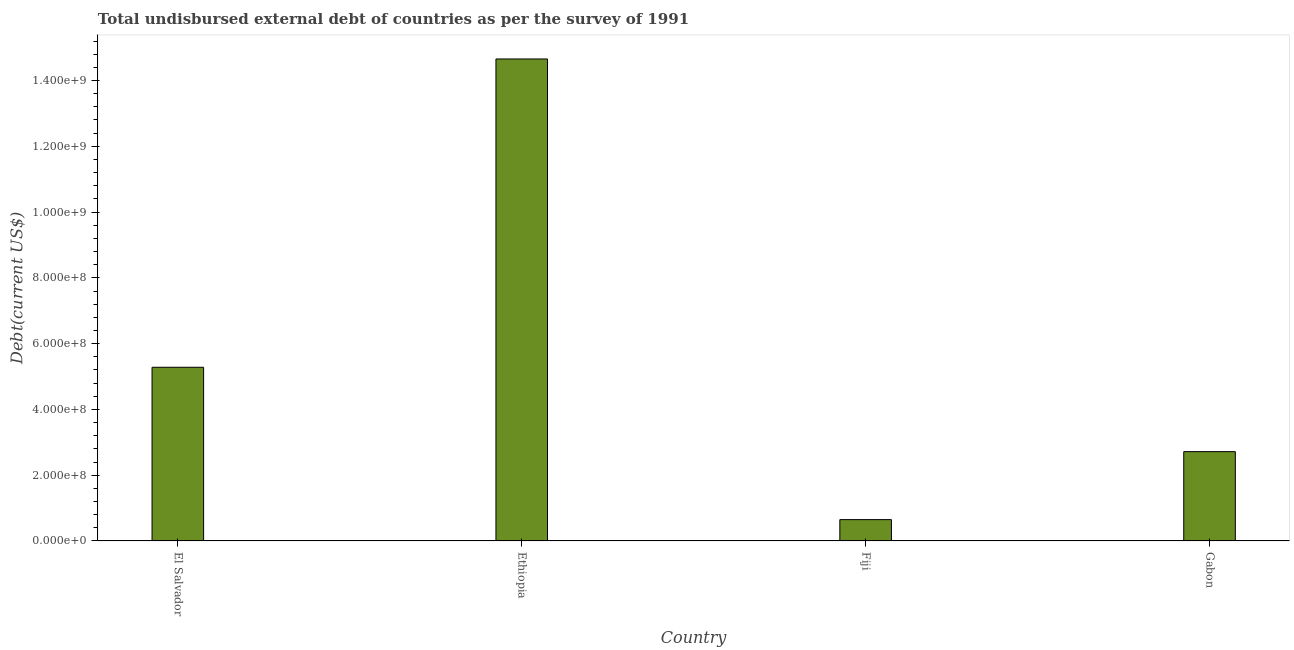Does the graph contain any zero values?
Your response must be concise. No. What is the title of the graph?
Make the answer very short. Total undisbursed external debt of countries as per the survey of 1991. What is the label or title of the X-axis?
Offer a terse response. Country. What is the label or title of the Y-axis?
Your answer should be compact. Debt(current US$). What is the total debt in Ethiopia?
Give a very brief answer. 1.47e+09. Across all countries, what is the maximum total debt?
Give a very brief answer. 1.47e+09. Across all countries, what is the minimum total debt?
Offer a very short reply. 6.49e+07. In which country was the total debt maximum?
Make the answer very short. Ethiopia. In which country was the total debt minimum?
Make the answer very short. Fiji. What is the sum of the total debt?
Offer a very short reply. 2.33e+09. What is the difference between the total debt in Ethiopia and Gabon?
Your answer should be very brief. 1.19e+09. What is the average total debt per country?
Offer a terse response. 5.83e+08. What is the median total debt?
Your answer should be very brief. 4.00e+08. What is the ratio of the total debt in El Salvador to that in Gabon?
Offer a very short reply. 1.94. Is the total debt in Ethiopia less than that in Fiji?
Make the answer very short. No. Is the difference between the total debt in Ethiopia and Gabon greater than the difference between any two countries?
Provide a succinct answer. No. What is the difference between the highest and the second highest total debt?
Make the answer very short. 9.37e+08. Is the sum of the total debt in El Salvador and Fiji greater than the maximum total debt across all countries?
Provide a short and direct response. No. What is the difference between the highest and the lowest total debt?
Ensure brevity in your answer.  1.40e+09. Are all the bars in the graph horizontal?
Provide a short and direct response. No. Are the values on the major ticks of Y-axis written in scientific E-notation?
Your answer should be very brief. Yes. What is the Debt(current US$) in El Salvador?
Provide a short and direct response. 5.28e+08. What is the Debt(current US$) in Ethiopia?
Make the answer very short. 1.47e+09. What is the Debt(current US$) in Fiji?
Your answer should be very brief. 6.49e+07. What is the Debt(current US$) of Gabon?
Keep it short and to the point. 2.72e+08. What is the difference between the Debt(current US$) in El Salvador and Ethiopia?
Offer a terse response. -9.37e+08. What is the difference between the Debt(current US$) in El Salvador and Fiji?
Offer a terse response. 4.63e+08. What is the difference between the Debt(current US$) in El Salvador and Gabon?
Provide a short and direct response. 2.57e+08. What is the difference between the Debt(current US$) in Ethiopia and Fiji?
Provide a short and direct response. 1.40e+09. What is the difference between the Debt(current US$) in Ethiopia and Gabon?
Your answer should be very brief. 1.19e+09. What is the difference between the Debt(current US$) in Fiji and Gabon?
Make the answer very short. -2.07e+08. What is the ratio of the Debt(current US$) in El Salvador to that in Ethiopia?
Your response must be concise. 0.36. What is the ratio of the Debt(current US$) in El Salvador to that in Fiji?
Provide a succinct answer. 8.13. What is the ratio of the Debt(current US$) in El Salvador to that in Gabon?
Offer a very short reply. 1.94. What is the ratio of the Debt(current US$) in Ethiopia to that in Fiji?
Offer a terse response. 22.57. What is the ratio of the Debt(current US$) in Ethiopia to that in Gabon?
Your answer should be very brief. 5.39. What is the ratio of the Debt(current US$) in Fiji to that in Gabon?
Your answer should be very brief. 0.24. 